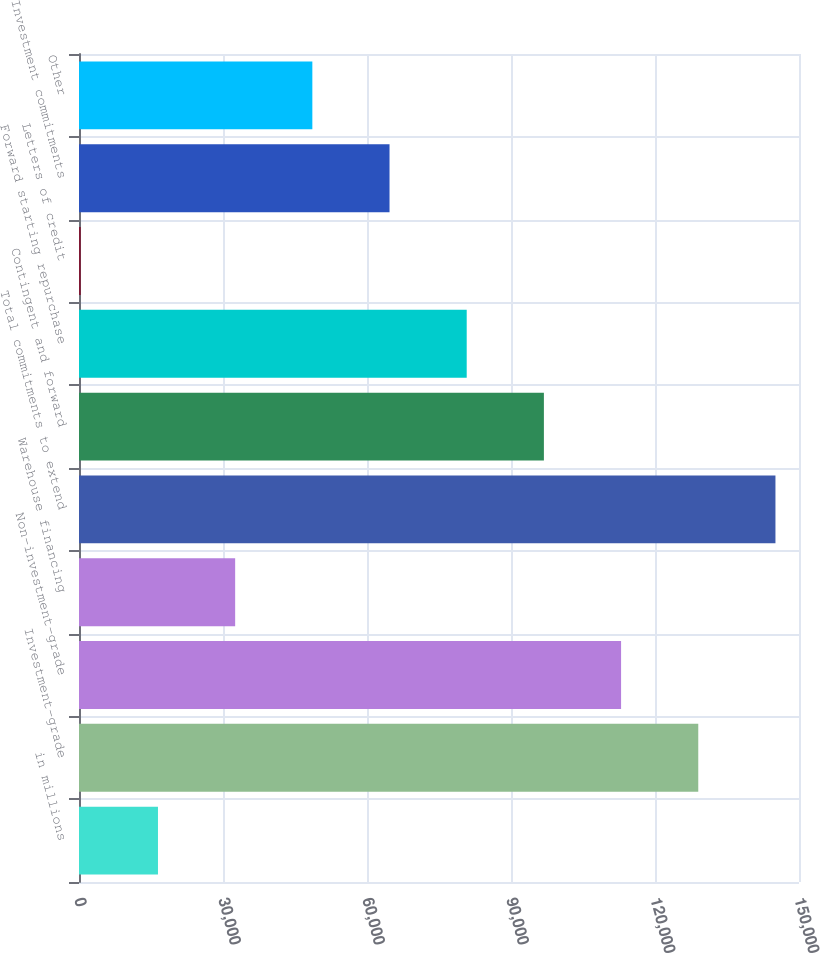<chart> <loc_0><loc_0><loc_500><loc_500><bar_chart><fcel>in millions<fcel>Investment-grade<fcel>Non-investment-grade<fcel>Warehouse financing<fcel>Total commitments to extend<fcel>Contingent and forward<fcel>Forward starting repurchase<fcel>Letters of credit<fcel>Investment commitments<fcel>Other<nl><fcel>16453.1<fcel>129014<fcel>112934<fcel>32533.2<fcel>145094<fcel>96853.6<fcel>80773.5<fcel>373<fcel>64693.4<fcel>48613.3<nl></chart> 